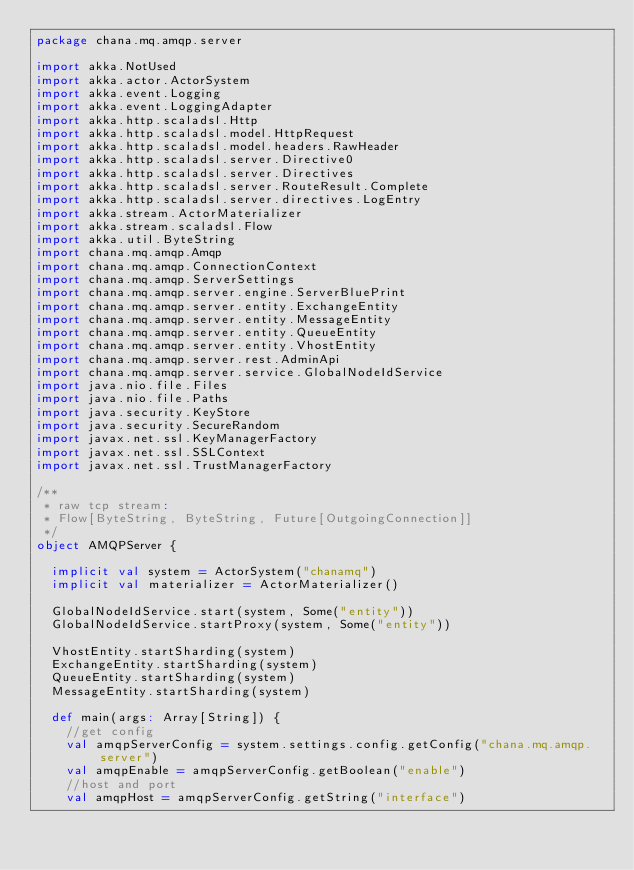Convert code to text. <code><loc_0><loc_0><loc_500><loc_500><_Scala_>package chana.mq.amqp.server

import akka.NotUsed
import akka.actor.ActorSystem
import akka.event.Logging
import akka.event.LoggingAdapter
import akka.http.scaladsl.Http
import akka.http.scaladsl.model.HttpRequest
import akka.http.scaladsl.model.headers.RawHeader
import akka.http.scaladsl.server.Directive0
import akka.http.scaladsl.server.Directives
import akka.http.scaladsl.server.RouteResult.Complete
import akka.http.scaladsl.server.directives.LogEntry
import akka.stream.ActorMaterializer
import akka.stream.scaladsl.Flow
import akka.util.ByteString
import chana.mq.amqp.Amqp
import chana.mq.amqp.ConnectionContext
import chana.mq.amqp.ServerSettings
import chana.mq.amqp.server.engine.ServerBluePrint
import chana.mq.amqp.server.entity.ExchangeEntity
import chana.mq.amqp.server.entity.MessageEntity
import chana.mq.amqp.server.entity.QueueEntity
import chana.mq.amqp.server.entity.VhostEntity
import chana.mq.amqp.server.rest.AdminApi
import chana.mq.amqp.server.service.GlobalNodeIdService
import java.nio.file.Files
import java.nio.file.Paths
import java.security.KeyStore
import java.security.SecureRandom
import javax.net.ssl.KeyManagerFactory
import javax.net.ssl.SSLContext
import javax.net.ssl.TrustManagerFactory

/**
 * raw tcp stream:
 * Flow[ByteString, ByteString, Future[OutgoingConnection]]
 */
object AMQPServer {

  implicit val system = ActorSystem("chanamq")
  implicit val materializer = ActorMaterializer()

  GlobalNodeIdService.start(system, Some("entity"))
  GlobalNodeIdService.startProxy(system, Some("entity"))

  VhostEntity.startSharding(system)
  ExchangeEntity.startSharding(system)
  QueueEntity.startSharding(system)
  MessageEntity.startSharding(system)

  def main(args: Array[String]) {
    //get config
    val amqpServerConfig = system.settings.config.getConfig("chana.mq.amqp.server")
    val amqpEnable = amqpServerConfig.getBoolean("enable")
    //host and port
    val amqpHost = amqpServerConfig.getString("interface")</code> 